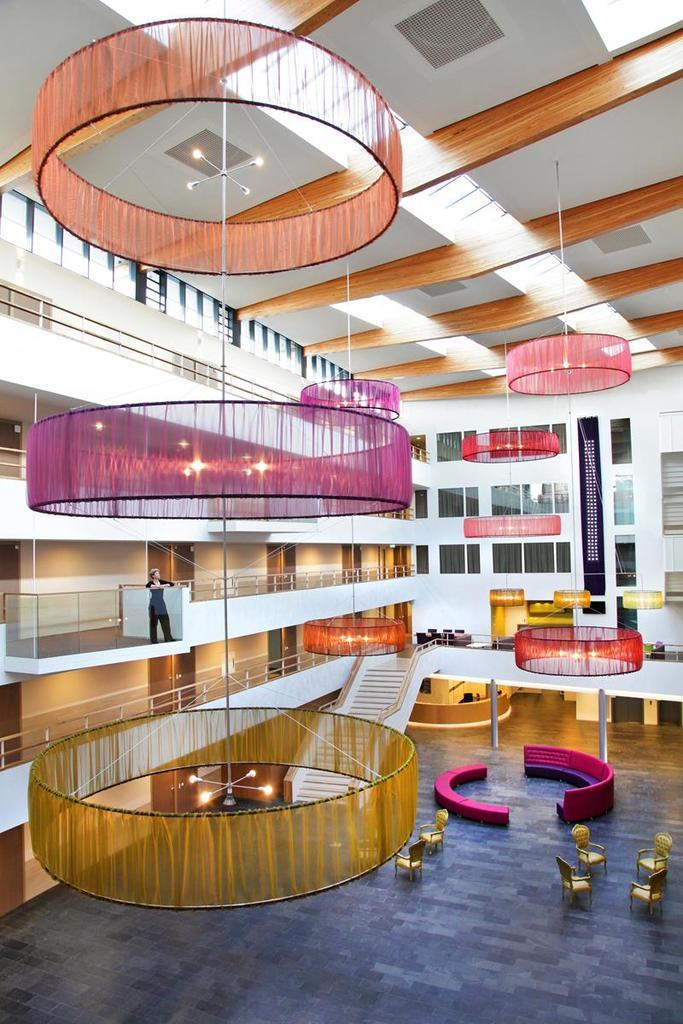What type of location is depicted in the image? The image shows an interior view of a building. What can be seen in the image that provides illumination? There are lights visible in the image. What type of furniture is present in the image? There are chairs and couches in the image. What architectural feature can be seen in the image? There is a staircase holder in the image. Is there a person present in the image? Yes, there is a person standing in the image. What type of waves can be seen crashing against the shore in the image? There are no waves or shore visible in the image; it depicts an interior view of a building. 